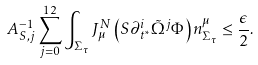<formula> <loc_0><loc_0><loc_500><loc_500>A _ { S , j } ^ { - 1 } \sum _ { j = 0 } ^ { 1 2 } \int _ { \Sigma _ { \tau } } J ^ { N } _ { \mu } \left ( S \partial _ { t ^ { * } } ^ { i } \tilde { \Omega } ^ { j } \Phi \right ) n ^ { \mu } _ { \Sigma _ { \tau } } \leq \frac { \epsilon } { 2 } .</formula> 